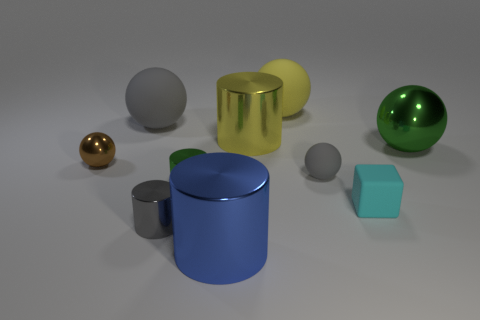What number of large objects are metallic things or gray matte blocks? There are two large metallic objects which appear to be a golden cylinder and a greenish sphere. Additionally, the image features a large gray matte block. So, there are three large objects in total that are either metallic or gray matte. 